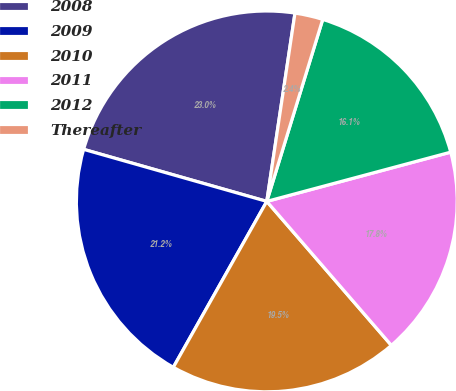Convert chart. <chart><loc_0><loc_0><loc_500><loc_500><pie_chart><fcel>2008<fcel>2009<fcel>2010<fcel>2011<fcel>2012<fcel>Thereafter<nl><fcel>22.96%<fcel>21.24%<fcel>19.52%<fcel>17.81%<fcel>16.09%<fcel>2.38%<nl></chart> 